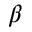<formula> <loc_0><loc_0><loc_500><loc_500>\beta</formula> 